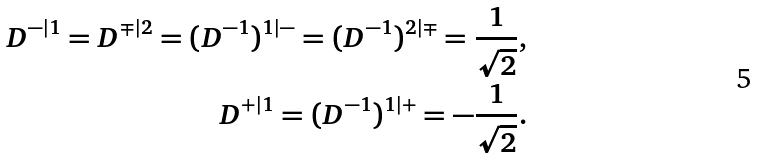<formula> <loc_0><loc_0><loc_500><loc_500>D ^ { - | 1 } = D ^ { \mp | 2 } = ( D ^ { - 1 } ) ^ { 1 | - } = ( D ^ { - 1 } ) ^ { 2 | \mp } = \frac { 1 } { \sqrt { 2 } } , \\ D ^ { + | 1 } = ( D ^ { - 1 } ) ^ { 1 | + } = - \frac { 1 } { \sqrt { 2 } } .</formula> 